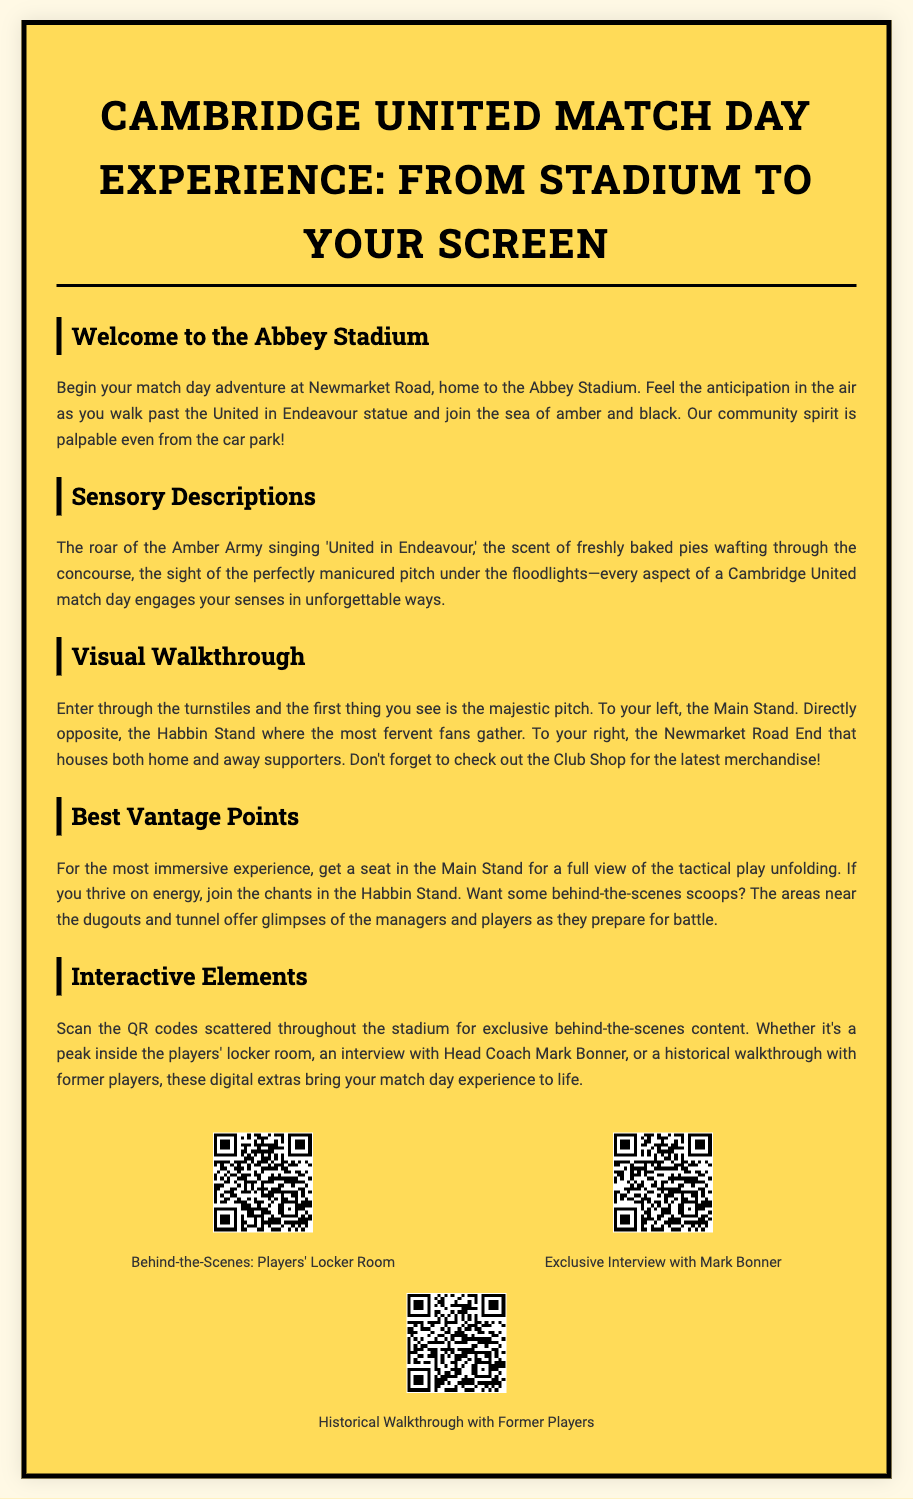What is the title of the playbill? The title is prominently displayed at the top of the document.
Answer: Cambridge United Match Day Experience: From Stadium to Your Screen Where is the Abbey Stadium located? The document mentions Newmarket Road as the location of Abbey Stadium.
Answer: Newmarket Road What odor can you smell as you enter the stadium? The document describes the scent that wafts through the concourse, engaging the senses.
Answer: Freshly baked pies Which stand is described as housing the most fervent fans? The document specifies which stand has passionate supporters.
Answer: Habbin Stand What is the best vantage point for tactical play? The document recommends a specific seat for a full view during the match.
Answer: Main Stand What type of content can be found by scanning QR codes? The document lists various exclusive content available to fans through QR codes.
Answer: Behind-the-scenes content Who is featured in the exclusive interview mentioned? The document names the individual who is interviewed, which can be found in the interactive section.
Answer: Mark Bonner What color is prominently associated with Cambridge United fans? The document touches on the community spirit and color representation of supporters.
Answer: Amber and black 